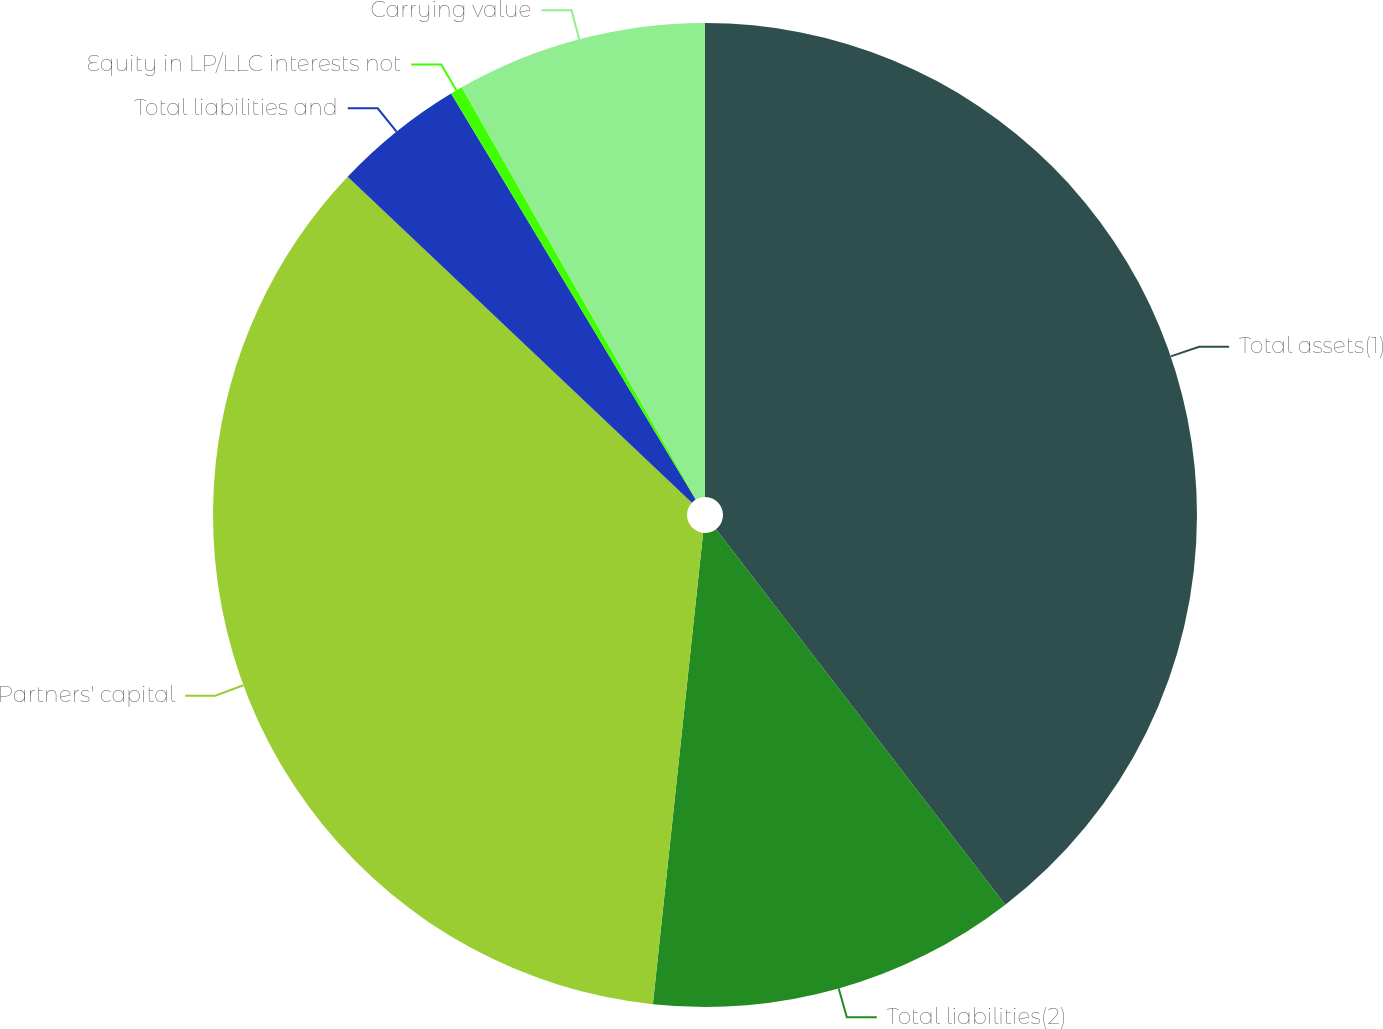<chart> <loc_0><loc_0><loc_500><loc_500><pie_chart><fcel>Total assets(1)<fcel>Total liabilities(2)<fcel>Partners' capital<fcel>Total liabilities and<fcel>Equity in LP/LLC interests not<fcel>Carrying value<nl><fcel>39.55%<fcel>12.14%<fcel>35.37%<fcel>4.31%<fcel>0.4%<fcel>8.23%<nl></chart> 